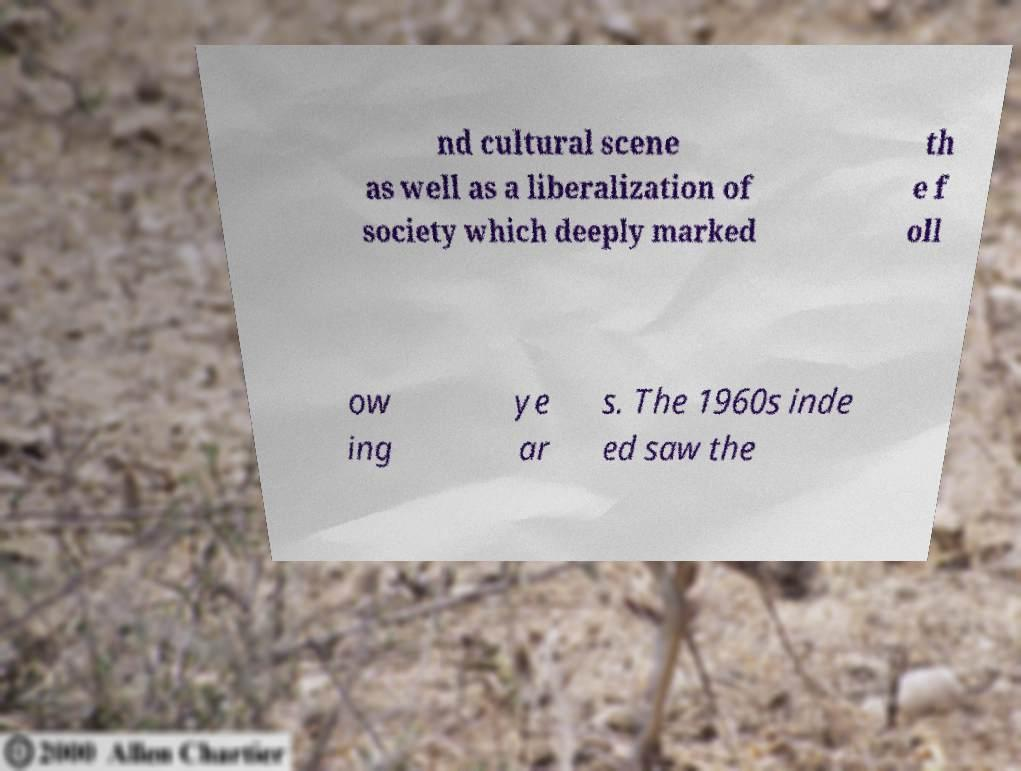For documentation purposes, I need the text within this image transcribed. Could you provide that? nd cultural scene as well as a liberalization of society which deeply marked th e f oll ow ing ye ar s. The 1960s inde ed saw the 